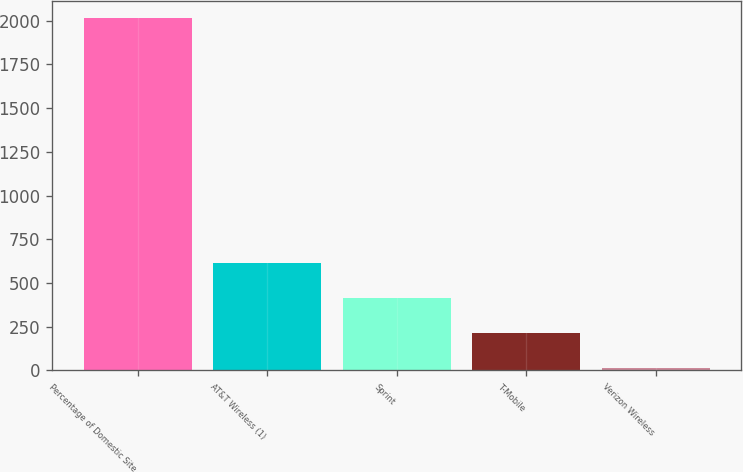Convert chart to OTSL. <chart><loc_0><loc_0><loc_500><loc_500><bar_chart><fcel>Percentage of Domestic Site<fcel>AT&T Wireless (1)<fcel>Sprint<fcel>T-Mobile<fcel>Verizon Wireless<nl><fcel>2014<fcel>614.28<fcel>414.32<fcel>214.36<fcel>14.4<nl></chart> 